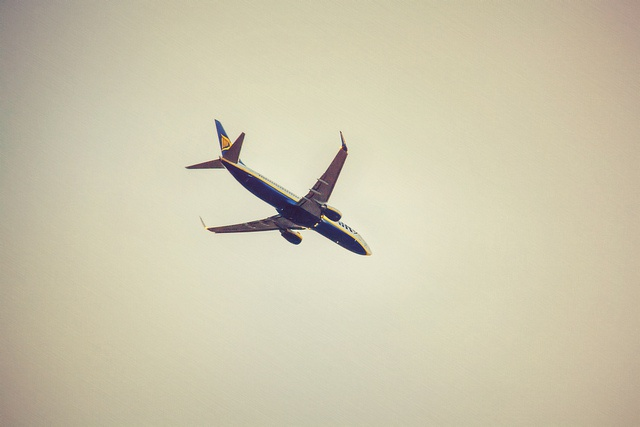Describe the objects in this image and their specific colors. I can see a airplane in gray, navy, beige, and purple tones in this image. 